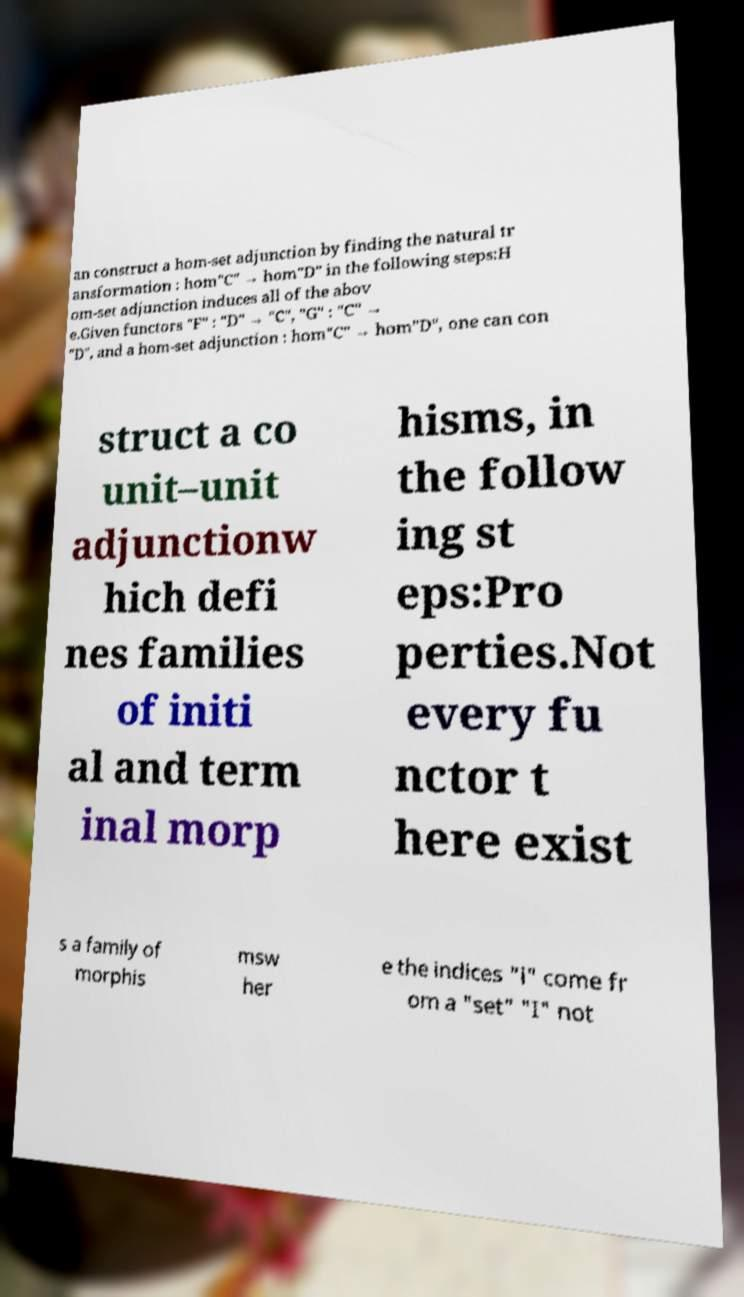Please read and relay the text visible in this image. What does it say? an construct a hom-set adjunction by finding the natural tr ansformation : hom"C" → hom"D" in the following steps:H om-set adjunction induces all of the abov e.Given functors "F" : "D" → "C", "G" : "C" → "D", and a hom-set adjunction : hom"C" → hom"D", one can con struct a co unit–unit adjunctionw hich defi nes families of initi al and term inal morp hisms, in the follow ing st eps:Pro perties.Not every fu nctor t here exist s a family of morphis msw her e the indices "i" come fr om a "set" "I" not 